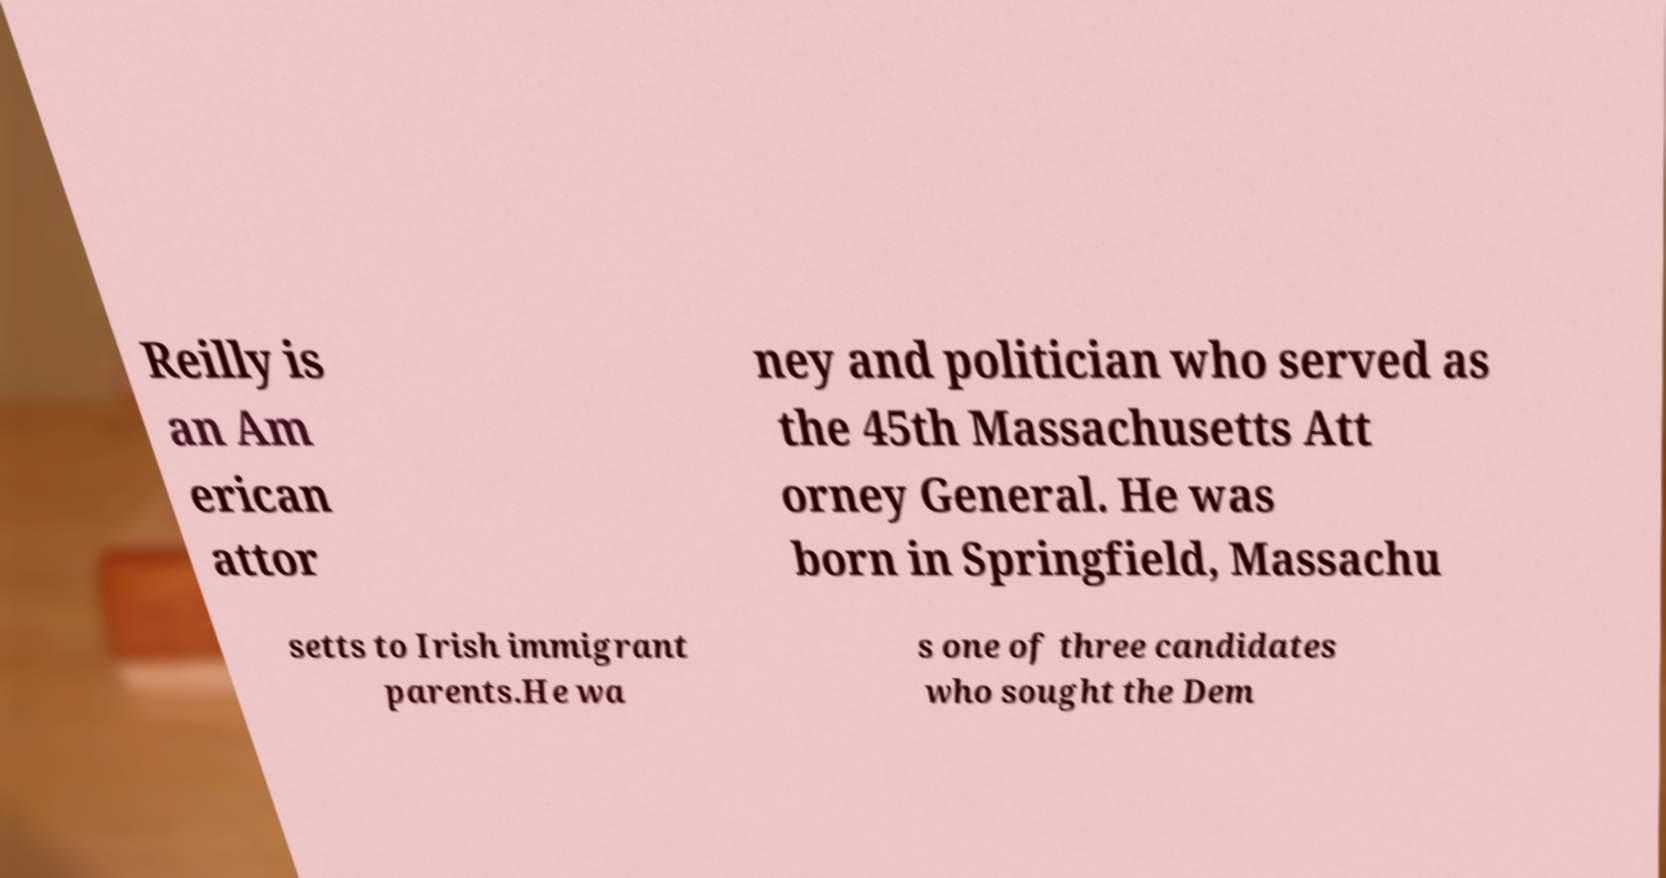Can you accurately transcribe the text from the provided image for me? Reilly is an Am erican attor ney and politician who served as the 45th Massachusetts Att orney General. He was born in Springfield, Massachu setts to Irish immigrant parents.He wa s one of three candidates who sought the Dem 